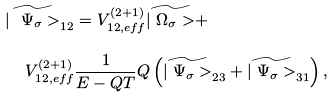Convert formula to latex. <formula><loc_0><loc_0><loc_500><loc_500>\widetilde { | \ \Psi _ { \sigma } > } _ { 1 2 } & = V ^ { ( 2 + 1 ) } _ { 1 2 , e f f } \widetilde { | \ \Omega _ { \sigma } > } + \\ V ^ { ( 2 + 1 ) } _ { 1 2 , e f f } & \frac { 1 } { E - Q T } Q \left ( \widetilde { | \ \Psi _ { \sigma } > } _ { 2 3 } + \widetilde { | \ \Psi _ { \sigma } > } _ { 3 1 } \right ) ,</formula> 